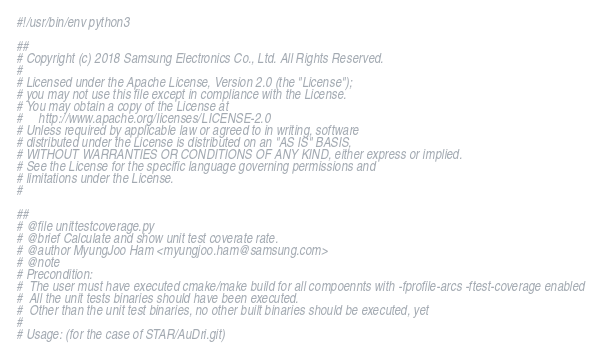Convert code to text. <code><loc_0><loc_0><loc_500><loc_500><_Python_>#!/usr/bin/env python3

##
# Copyright (c) 2018 Samsung Electronics Co., Ltd. All Rights Reserved.
#
# Licensed under the Apache License, Version 2.0 (the "License");
# you may not use this file except in compliance with the License.
# You may obtain a copy of the License at
#     http://www.apache.org/licenses/LICENSE-2.0
# Unless required by applicable law or agreed to in writing, software
# distributed under the License is distributed on an "AS IS" BASIS,
# WITHOUT WARRANTIES OR CONDITIONS OF ANY KIND, either express or implied.
# See the License for the specific language governing permissions and
# limitations under the License.
#

##
# @file unittestcoverage.py
# @brief Calculate and show unit test coverate rate.
# @author MyungJoo Ham <myungjoo.ham@samsung.com>
# @note
# Precondition:
#  The user must have executed cmake/make build for all compoennts with -fprofile-arcs -ftest-coverage enabled
#  All the unit tests binaries should have been executed.
#  Other than the unit test binaries, no other built binaries should be executed, yet
#
# Usage: (for the case of STAR/AuDri.git)</code> 